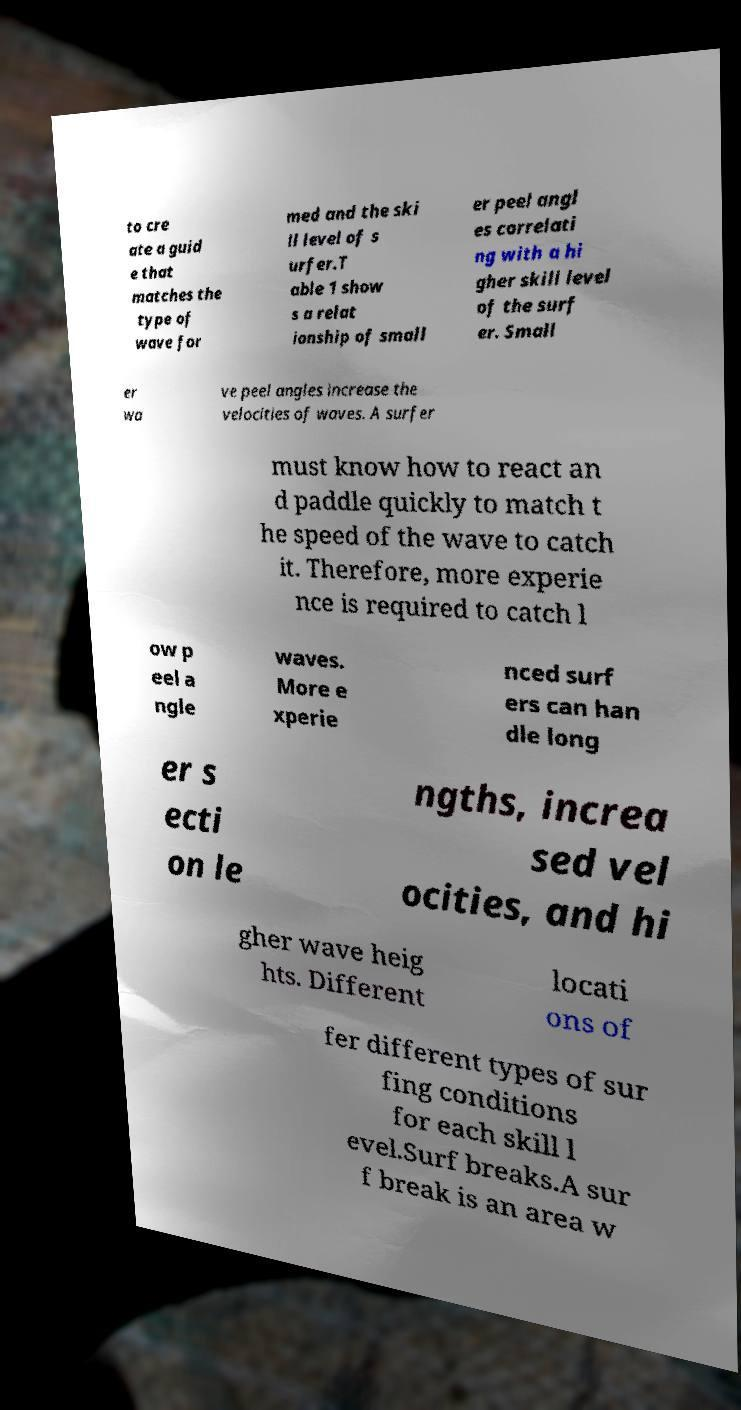Please identify and transcribe the text found in this image. to cre ate a guid e that matches the type of wave for med and the ski ll level of s urfer.T able 1 show s a relat ionship of small er peel angl es correlati ng with a hi gher skill level of the surf er. Small er wa ve peel angles increase the velocities of waves. A surfer must know how to react an d paddle quickly to match t he speed of the wave to catch it. Therefore, more experie nce is required to catch l ow p eel a ngle waves. More e xperie nced surf ers can han dle long er s ecti on le ngths, increa sed vel ocities, and hi gher wave heig hts. Different locati ons of fer different types of sur fing conditions for each skill l evel.Surf breaks.A sur f break is an area w 